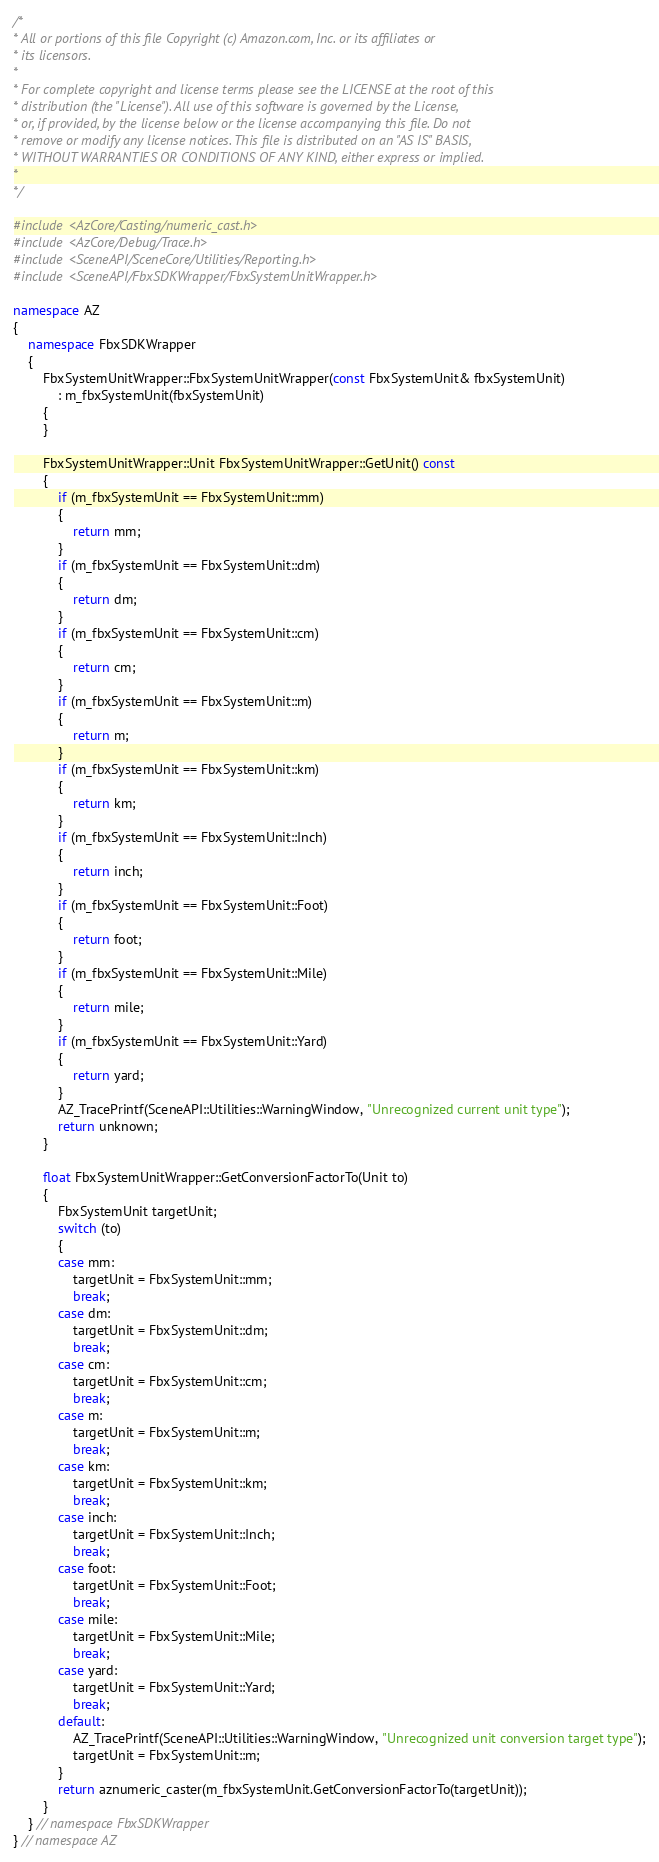<code> <loc_0><loc_0><loc_500><loc_500><_C++_>/*
* All or portions of this file Copyright (c) Amazon.com, Inc. or its affiliates or
* its licensors.
*
* For complete copyright and license terms please see the LICENSE at the root of this
* distribution (the "License"). All use of this software is governed by the License,
* or, if provided, by the license below or the license accompanying this file. Do not
* remove or modify any license notices. This file is distributed on an "AS IS" BASIS,
* WITHOUT WARRANTIES OR CONDITIONS OF ANY KIND, either express or implied.
*
*/

#include <AzCore/Casting/numeric_cast.h>
#include <AzCore/Debug/Trace.h>
#include <SceneAPI/SceneCore/Utilities/Reporting.h>
#include <SceneAPI/FbxSDKWrapper/FbxSystemUnitWrapper.h>

namespace AZ
{
    namespace FbxSDKWrapper
    {
        FbxSystemUnitWrapper::FbxSystemUnitWrapper(const FbxSystemUnit& fbxSystemUnit)
            : m_fbxSystemUnit(fbxSystemUnit)
        {
        }

        FbxSystemUnitWrapper::Unit FbxSystemUnitWrapper::GetUnit() const
        {
            if (m_fbxSystemUnit == FbxSystemUnit::mm)
            {
                return mm;
            }
            if (m_fbxSystemUnit == FbxSystemUnit::dm)
            {
                return dm;
            }
            if (m_fbxSystemUnit == FbxSystemUnit::cm)
            {
                return cm;
            }
            if (m_fbxSystemUnit == FbxSystemUnit::m)
            {
                return m;
            }
            if (m_fbxSystemUnit == FbxSystemUnit::km)
            {
                return km;
            }
            if (m_fbxSystemUnit == FbxSystemUnit::Inch)
            {
                return inch;
            }
            if (m_fbxSystemUnit == FbxSystemUnit::Foot)
            {
                return foot;
            }
            if (m_fbxSystemUnit == FbxSystemUnit::Mile)
            {
                return mile;
            }
            if (m_fbxSystemUnit == FbxSystemUnit::Yard)
            {
                return yard;
            }
            AZ_TracePrintf(SceneAPI::Utilities::WarningWindow, "Unrecognized current unit type");
            return unknown;
        }

        float FbxSystemUnitWrapper::GetConversionFactorTo(Unit to)
        {
            FbxSystemUnit targetUnit;
            switch (to)
            {
            case mm:
                targetUnit = FbxSystemUnit::mm;
                break;
            case dm:
                targetUnit = FbxSystemUnit::dm;
                break;
            case cm:
                targetUnit = FbxSystemUnit::cm;
                break;
            case m:
                targetUnit = FbxSystemUnit::m;
                break;
            case km:
                targetUnit = FbxSystemUnit::km;
                break;
            case inch:
                targetUnit = FbxSystemUnit::Inch;
                break;
            case foot:
                targetUnit = FbxSystemUnit::Foot;
                break;
            case mile:
                targetUnit = FbxSystemUnit::Mile;
                break;
            case yard:
                targetUnit = FbxSystemUnit::Yard;
                break;
            default:
                AZ_TracePrintf(SceneAPI::Utilities::WarningWindow, "Unrecognized unit conversion target type");
                targetUnit = FbxSystemUnit::m;
            }
            return aznumeric_caster(m_fbxSystemUnit.GetConversionFactorTo(targetUnit));
        }
    } // namespace FbxSDKWrapper
} // namespace AZ
</code> 